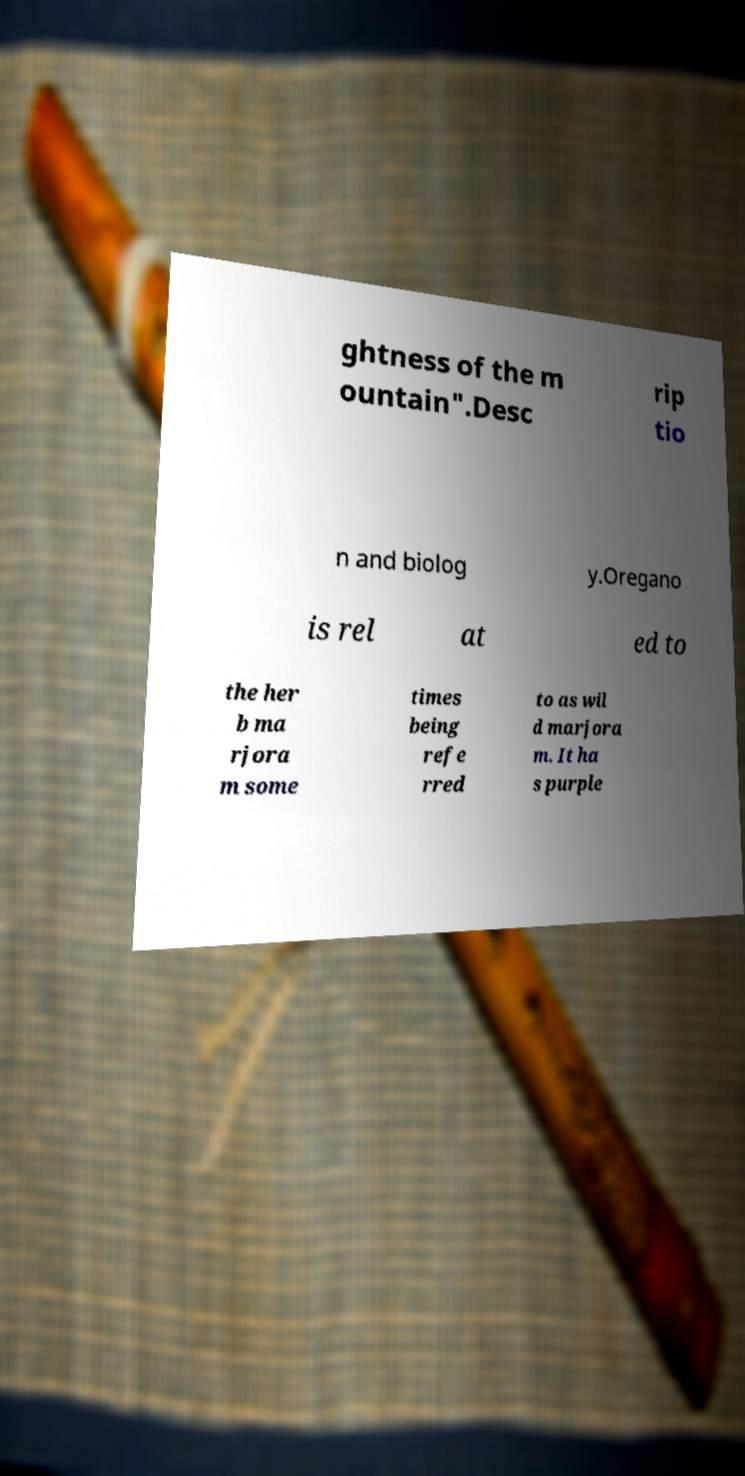What messages or text are displayed in this image? I need them in a readable, typed format. ghtness of the m ountain".Desc rip tio n and biolog y.Oregano is rel at ed to the her b ma rjora m some times being refe rred to as wil d marjora m. It ha s purple 